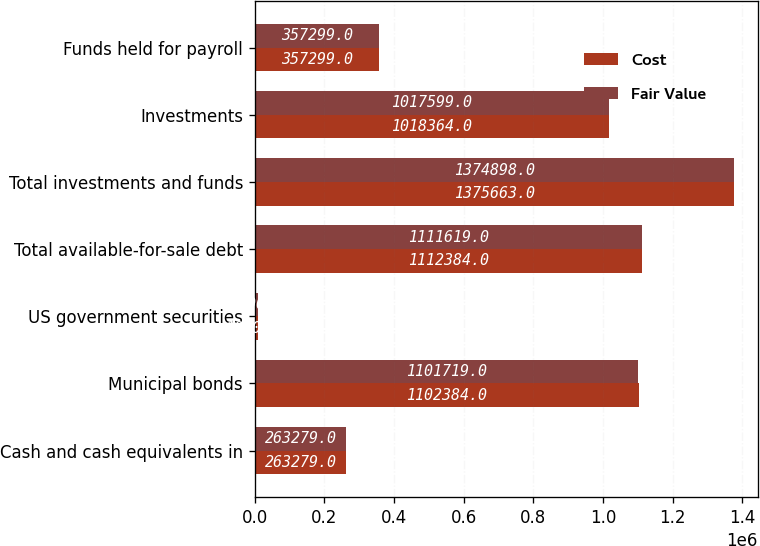Convert chart. <chart><loc_0><loc_0><loc_500><loc_500><stacked_bar_chart><ecel><fcel>Cash and cash equivalents in<fcel>Municipal bonds<fcel>US government securities<fcel>Total available-for-sale debt<fcel>Total investments and funds<fcel>Investments<fcel>Funds held for payroll<nl><fcel>Cost<fcel>263279<fcel>1.10238e+06<fcel>10000<fcel>1.11238e+06<fcel>1.37566e+06<fcel>1.01836e+06<fcel>357299<nl><fcel>Fair Value<fcel>263279<fcel>1.10172e+06<fcel>9900<fcel>1.11162e+06<fcel>1.3749e+06<fcel>1.0176e+06<fcel>357299<nl></chart> 